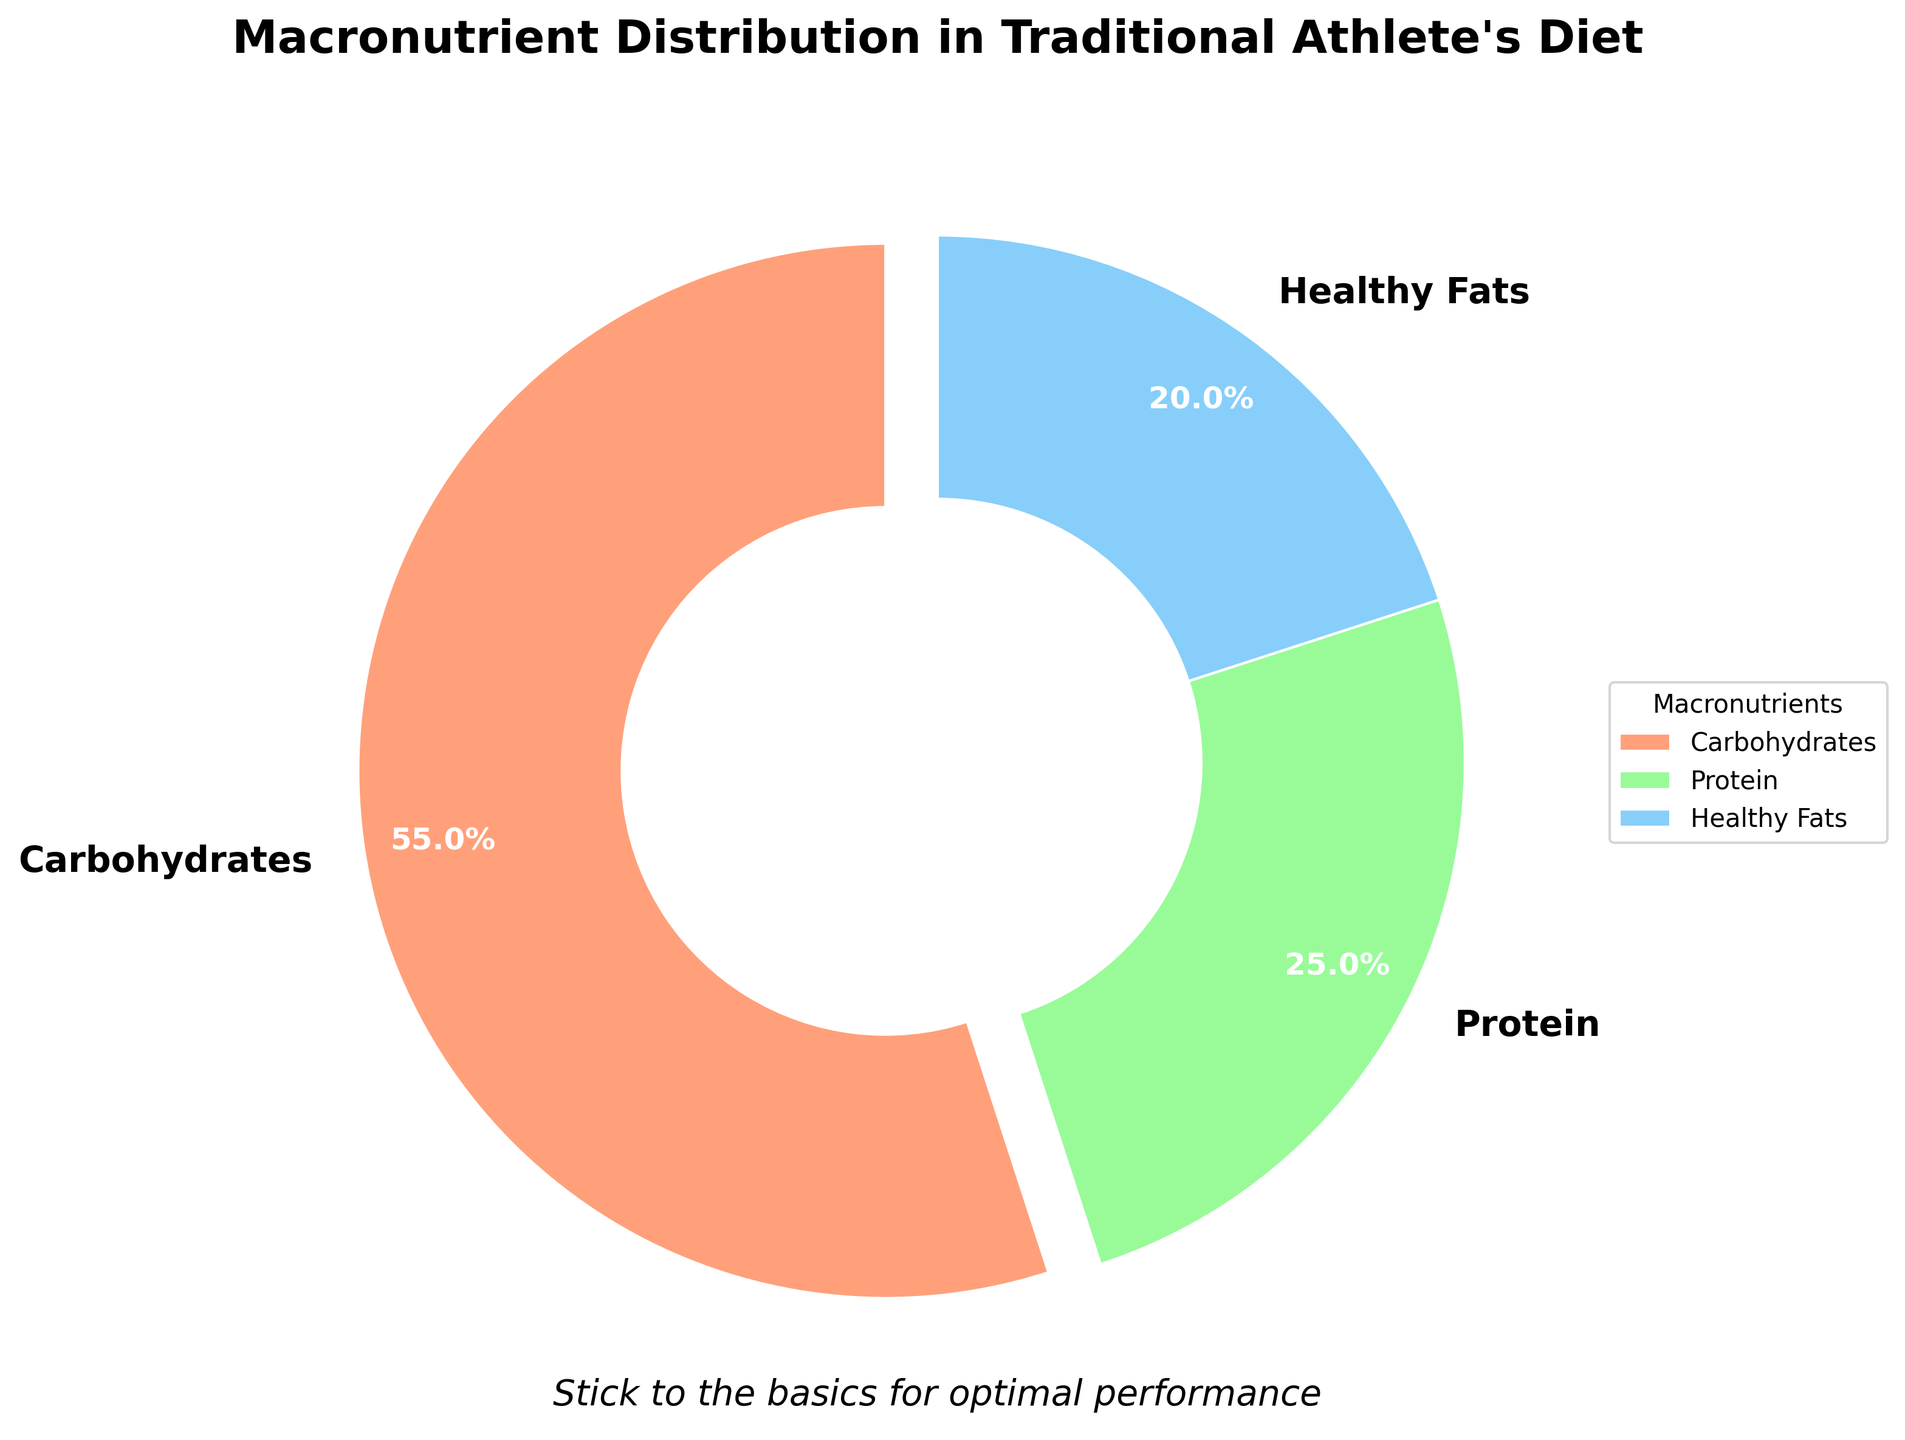What is the proportion of carbohydrates in the traditional athlete's diet? The pie chart shows that carbohydrates make up 55% of the distribution.
Answer: 55% What macronutrient has the smallest proportion in this diet? By comparing the percentages shown in the pie chart, healthy fats have the smallest proportion at 20%.
Answer: Healthy fats What is the combined percentage of protein and healthy fats in this diet? By adding the proportions of protein (25%) and healthy fats (20%), the total is 45%.
Answer: 45% Is the proportion of carbohydrates greater than the combined proportion of protein and healthy fats? The pie chart shows carbohydrates at 55%, while the combined protein and healthy fats are 45%. Since 55% is greater than 45%, carbohydrates have a larger proportion.
Answer: Yes How many times greater is the proportion of carbohydrates compared to healthy fats? The percentage of carbohydrates is 55%, and healthy fats are 20%. Dividing 55 by 20 gives 2.75.
Answer: 2.75 times Which macronutrient has the highest proportion in the diet? According to the pie chart, carbohydrates have the highest proportion at 55%.
Answer: Carbohydrates What proportion of the diet is not protein? The total percentage of the diet that is not protein includes carbohydrates and healthy fats. Adding their proportions (55% and 20%) gives 75%.
Answer: 75% What is the percentage difference between the proportions of carbohydrates and protein? Subtracting the protein proportion (25%) from the carbohydrate proportion (55%) gives a difference of 30%.
Answer: 30% What colors are used to represent carbohydrates, proteins, and healthy fats? The pie chart uses red to represent carbohydrates, green to represent proteins, and blue to represent healthy fats.
Answer: Red, Green, Blue 